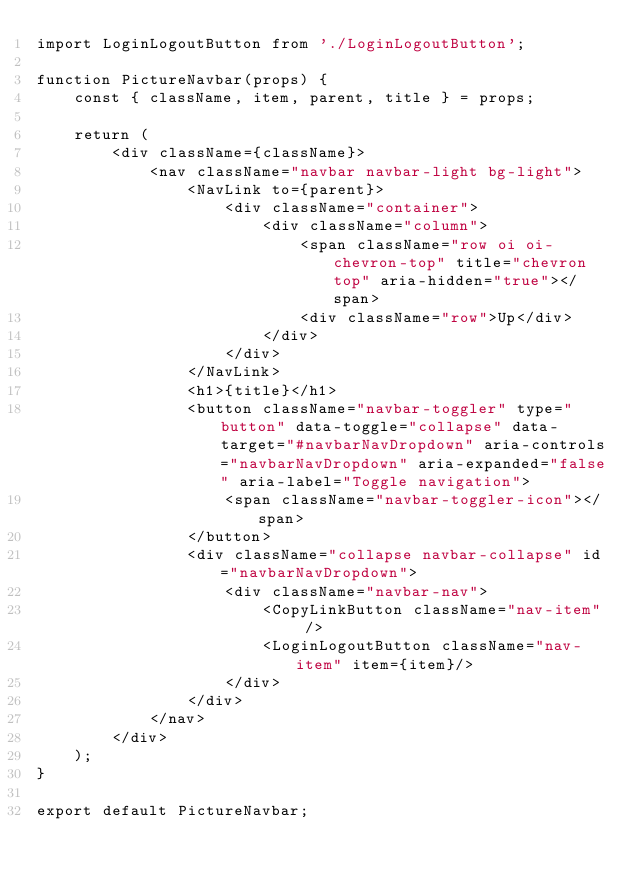Convert code to text. <code><loc_0><loc_0><loc_500><loc_500><_JavaScript_>import LoginLogoutButton from './LoginLogoutButton';

function PictureNavbar(props) {
    const { className, item, parent, title } = props;

    return (
        <div className={className}>
            <nav className="navbar navbar-light bg-light">
                <NavLink to={parent}>
                    <div className="container">
                        <div className="column">
                            <span className="row oi oi-chevron-top" title="chevron top" aria-hidden="true"></span>
                            <div className="row">Up</div>
                        </div>
                    </div>
                </NavLink>
                <h1>{title}</h1>
                <button className="navbar-toggler" type="button" data-toggle="collapse" data-target="#navbarNavDropdown" aria-controls="navbarNavDropdown" aria-expanded="false" aria-label="Toggle navigation">
                    <span className="navbar-toggler-icon"></span>
                </button>
                <div className="collapse navbar-collapse" id="navbarNavDropdown">
                    <div className="navbar-nav">
                        <CopyLinkButton className="nav-item" />
                        <LoginLogoutButton className="nav-item" item={item}/>
                    </div>
                </div>
            </nav>
        </div>
    );
}

export default PictureNavbar;
</code> 